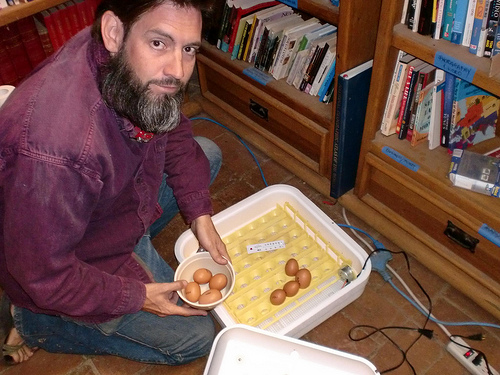<image>
Is the man on the books? No. The man is not positioned on the books. They may be near each other, but the man is not supported by or resting on top of the books. Where is the man in relation to the food? Is it behind the food? No. The man is not behind the food. From this viewpoint, the man appears to be positioned elsewhere in the scene. Where is the eggs in relation to the person? Is it next to the person? Yes. The eggs is positioned adjacent to the person, located nearby in the same general area. 